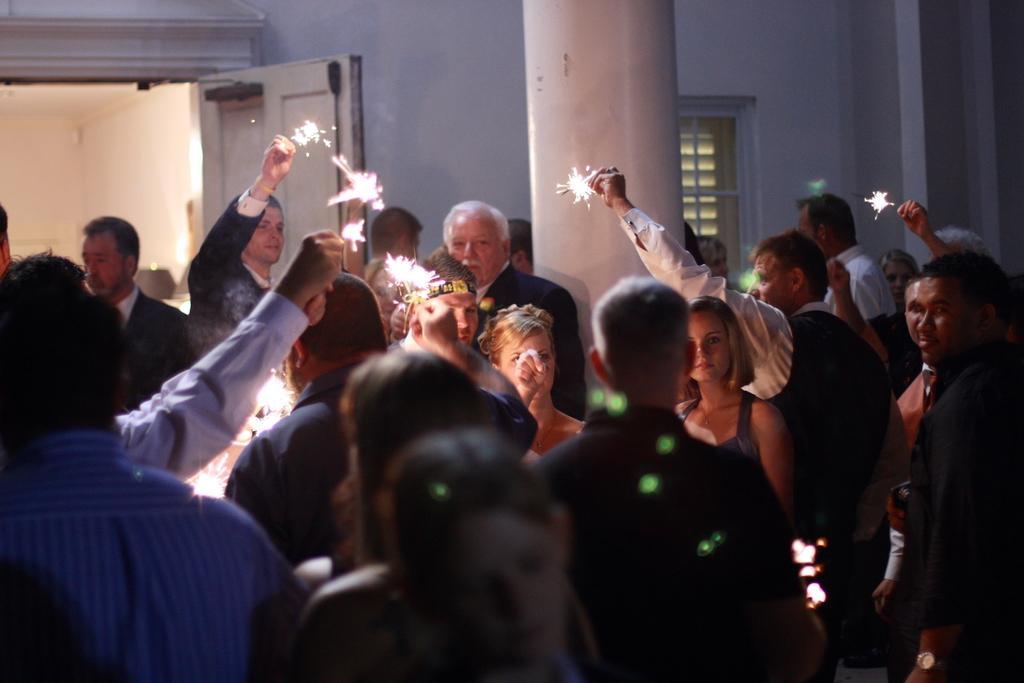Describe this image in one or two sentences. In this picture there are people in the image, they are lighting crackers in the image and there is a pillar at the top side of the image and there is a door and a window in the background area of the image. 